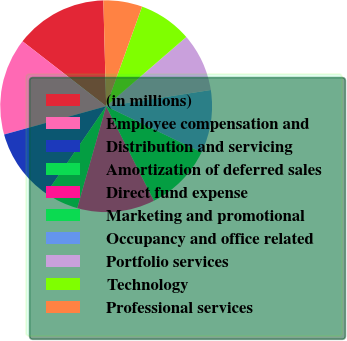Convert chart. <chart><loc_0><loc_0><loc_500><loc_500><pie_chart><fcel>(in millions)<fcel>Employee compensation and<fcel>Distribution and servicing<fcel>Amortization of deferred sales<fcel>Direct fund expense<fcel>Marketing and promotional<fcel>Occupancy and office related<fcel>Portfolio services<fcel>Technology<fcel>Professional services<nl><fcel>14.07%<fcel>14.81%<fcel>11.11%<fcel>5.19%<fcel>11.85%<fcel>10.37%<fcel>9.63%<fcel>8.89%<fcel>8.15%<fcel>5.93%<nl></chart> 